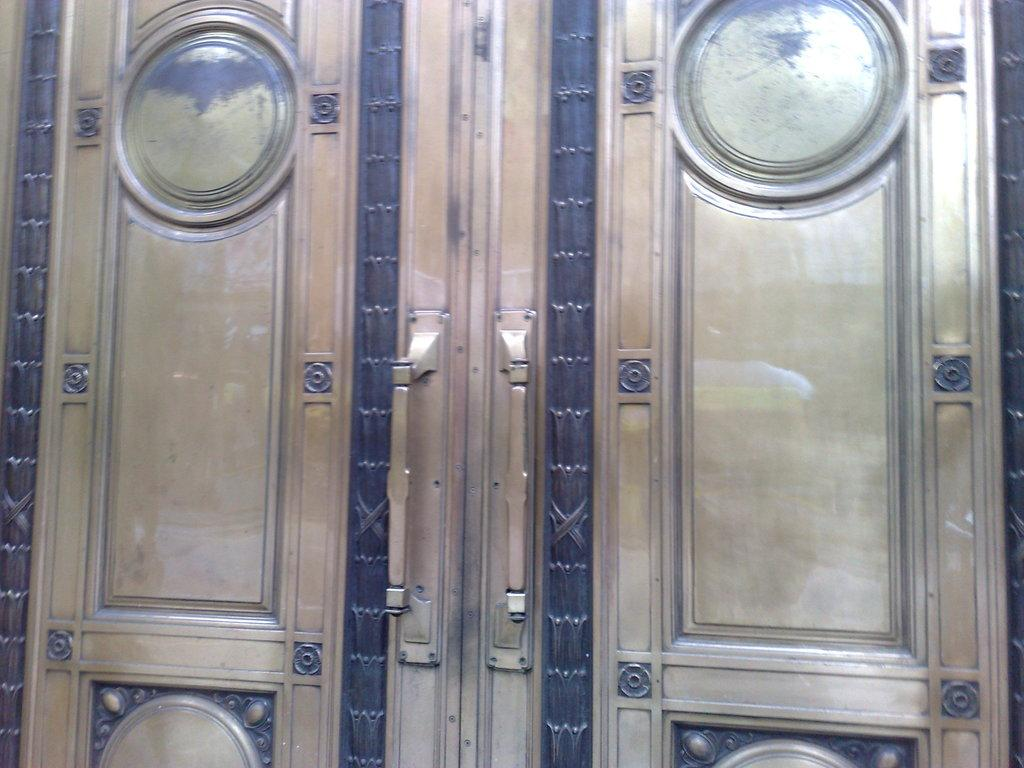What is the main object in the picture? There is a door in the picture. What material is the handle of the door made of? The door has a metal handle. What type of frame surrounds the door? The door has a metal frame. How many books are stacked on top of the door in the image? There are no books stacked on top of the door in the image. 